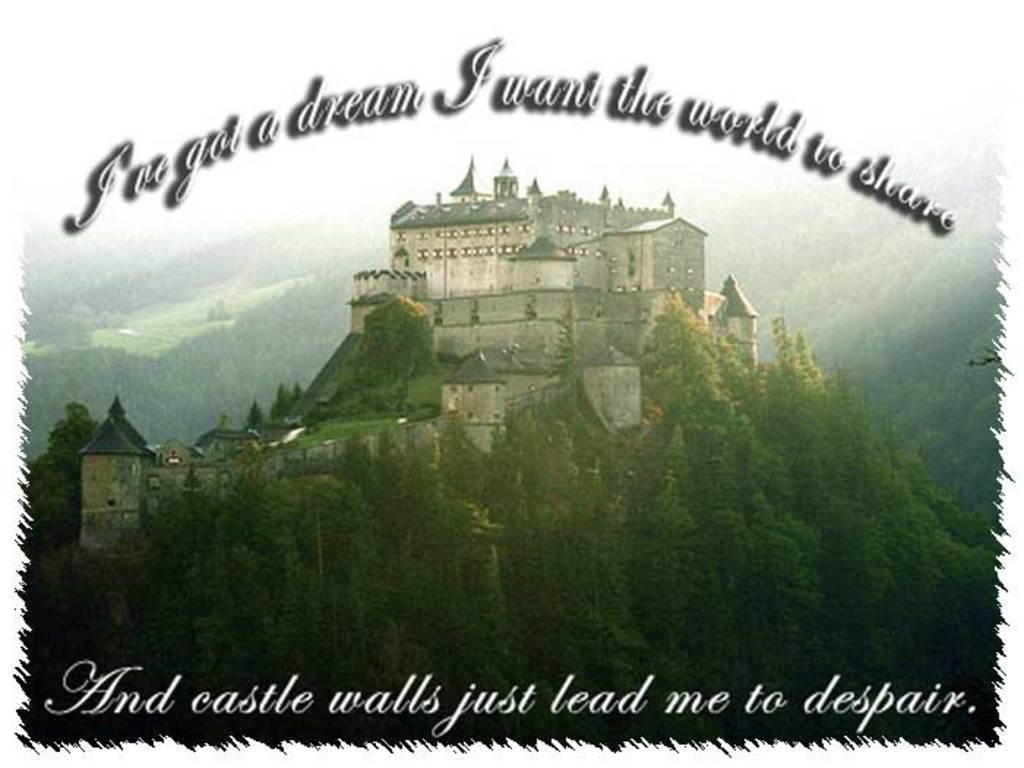Describe this image in one or two sentences. In this image we can see a castle and there are trees. At the top and bottom there is text. 